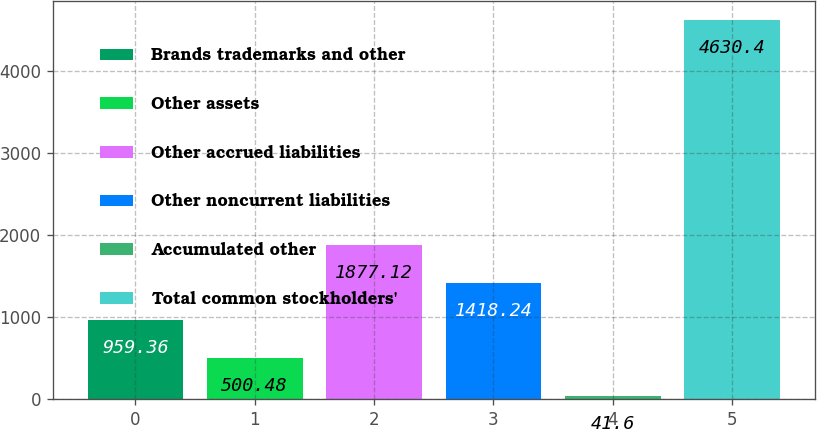Convert chart. <chart><loc_0><loc_0><loc_500><loc_500><bar_chart><fcel>Brands trademarks and other<fcel>Other assets<fcel>Other accrued liabilities<fcel>Other noncurrent liabilities<fcel>Accumulated other<fcel>Total common stockholders'<nl><fcel>959.36<fcel>500.48<fcel>1877.12<fcel>1418.24<fcel>41.6<fcel>4630.4<nl></chart> 